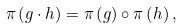Convert formula to latex. <formula><loc_0><loc_0><loc_500><loc_500>\pi \left ( g \cdot h \right ) = \pi \left ( g \right ) \circ \pi \left ( h \right ) ,</formula> 